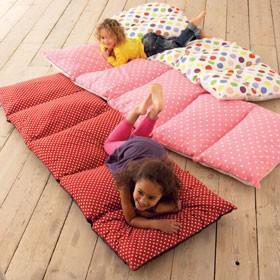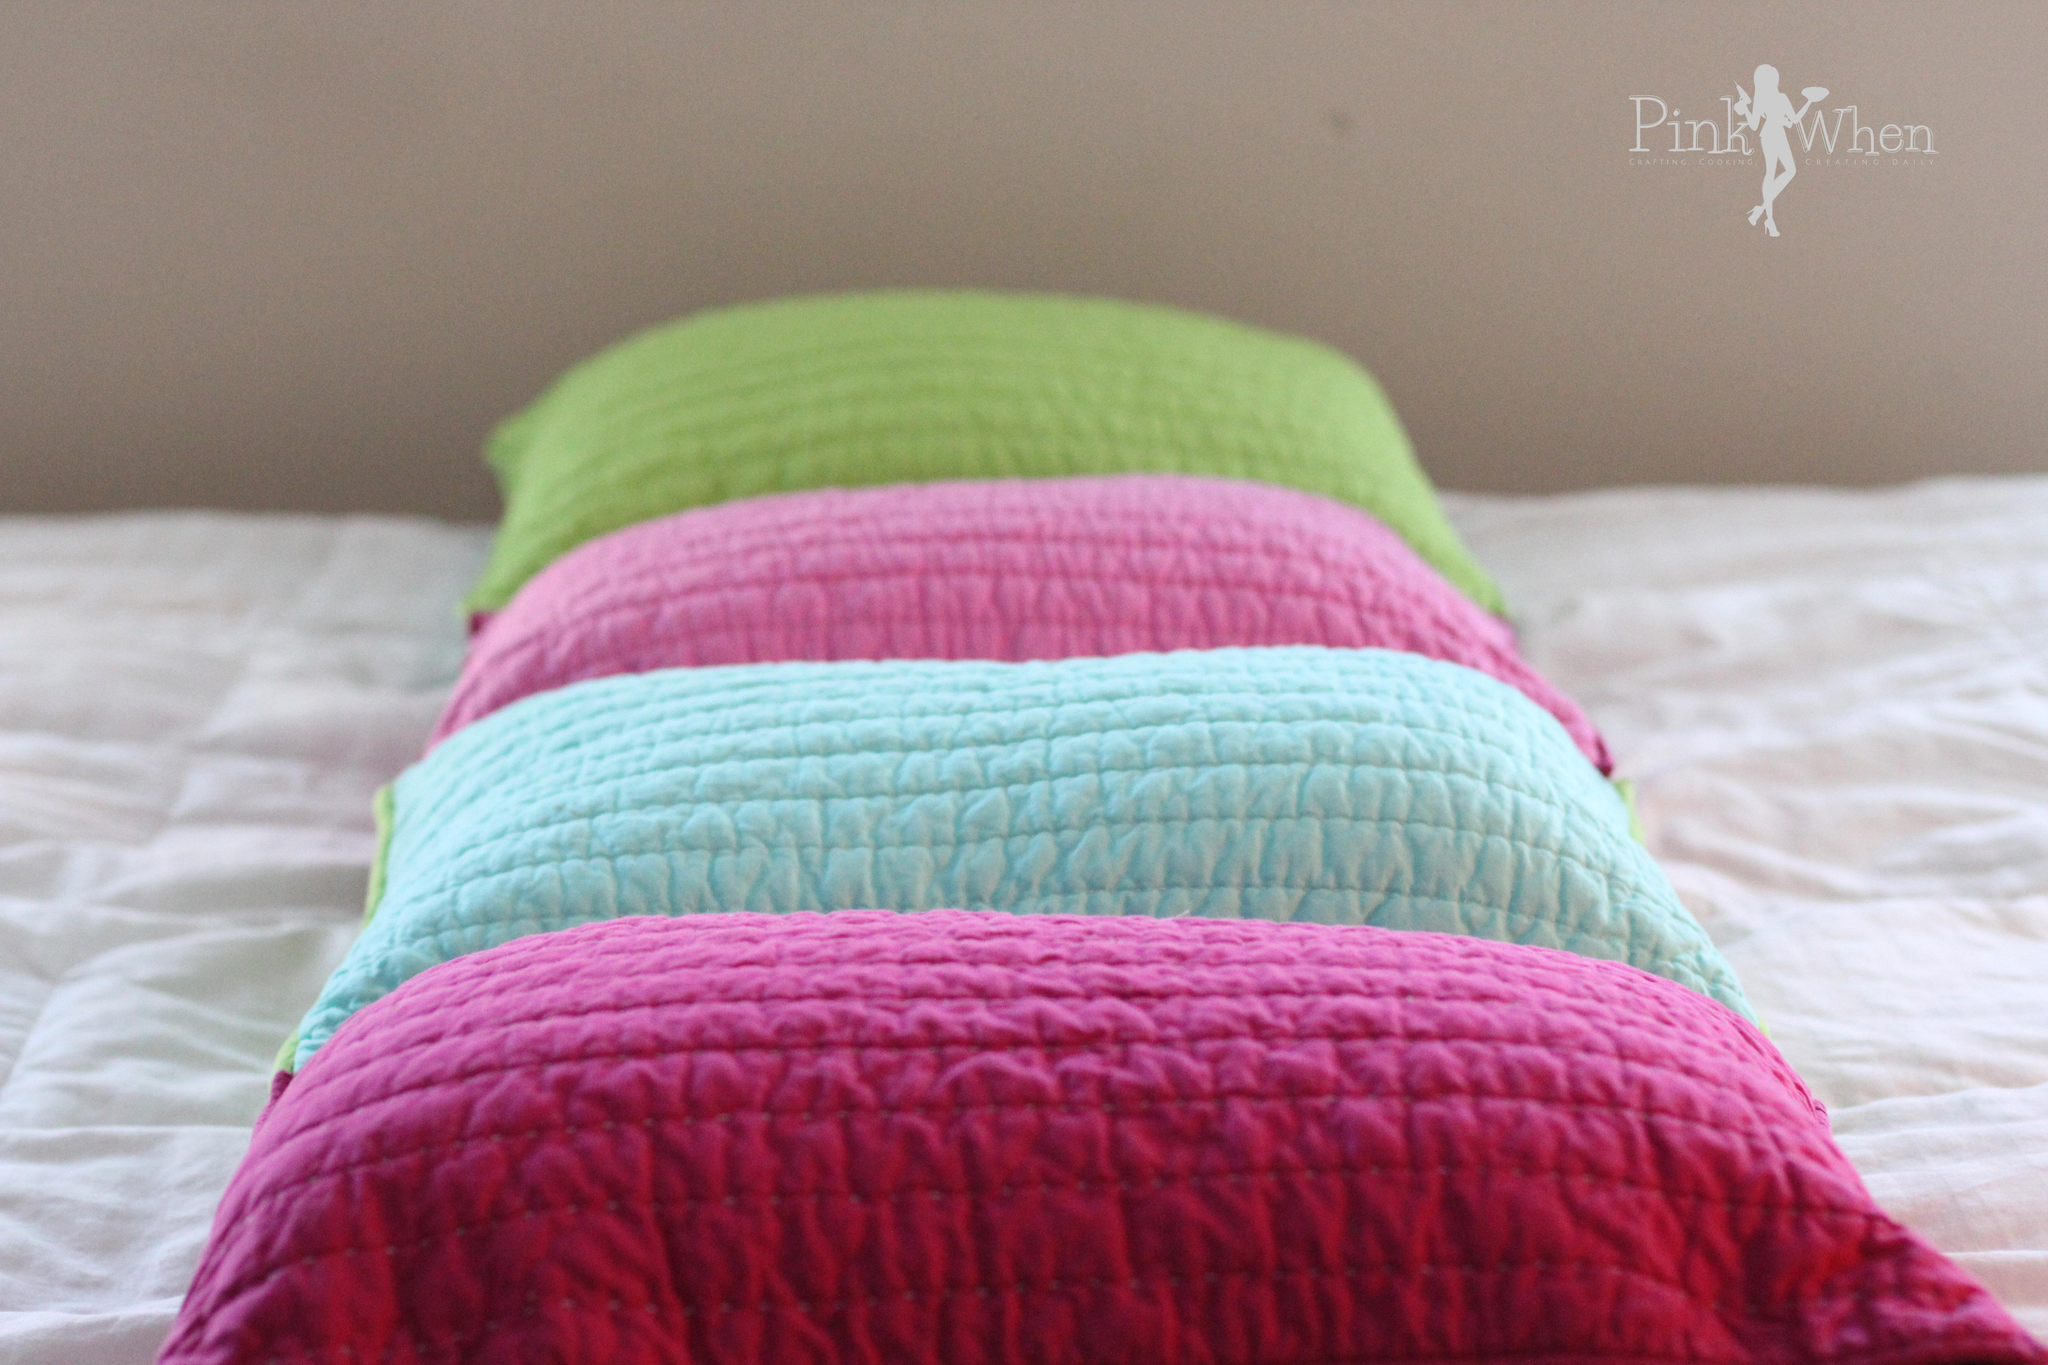The first image is the image on the left, the second image is the image on the right. For the images displayed, is the sentence "In the left image two kids are holding pillows" factually correct? Answer yes or no. No. 